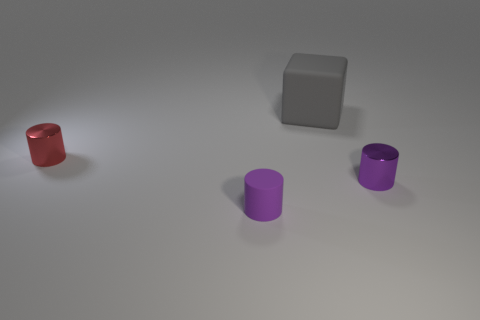What number of other things are the same color as the rubber cylinder?
Give a very brief answer. 1. How many things are either large green shiny things or purple cylinders right of the small purple matte thing?
Ensure brevity in your answer.  1. What number of gray rubber blocks are on the right side of the rubber thing that is behind the metallic thing that is on the left side of the big gray thing?
Provide a succinct answer. 0. The other thing that is made of the same material as the big object is what color?
Offer a terse response. Purple. Does the metal cylinder that is to the right of the red shiny object have the same size as the tiny matte object?
Offer a very short reply. Yes. How many things are big cyan matte cubes or tiny purple things?
Provide a succinct answer. 2. There is a thing to the right of the matte object behind the small thing on the right side of the large gray object; what is its material?
Offer a very short reply. Metal. There is a small cylinder to the right of the tiny purple matte cylinder; what material is it?
Ensure brevity in your answer.  Metal. Is there a red cylinder of the same size as the purple matte thing?
Make the answer very short. Yes. There is a tiny metallic object that is in front of the small red metal thing; is it the same color as the big matte thing?
Ensure brevity in your answer.  No. 